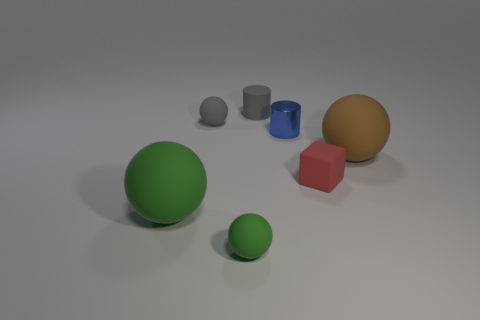Subtract all green balls. How many were subtracted if there are1green balls left? 1 Add 2 large cyan rubber blocks. How many objects exist? 9 Subtract all balls. How many objects are left? 3 Subtract 0 yellow balls. How many objects are left? 7 Subtract all cyan rubber cylinders. Subtract all big objects. How many objects are left? 5 Add 4 cylinders. How many cylinders are left? 6 Add 7 big metal balls. How many big metal balls exist? 7 